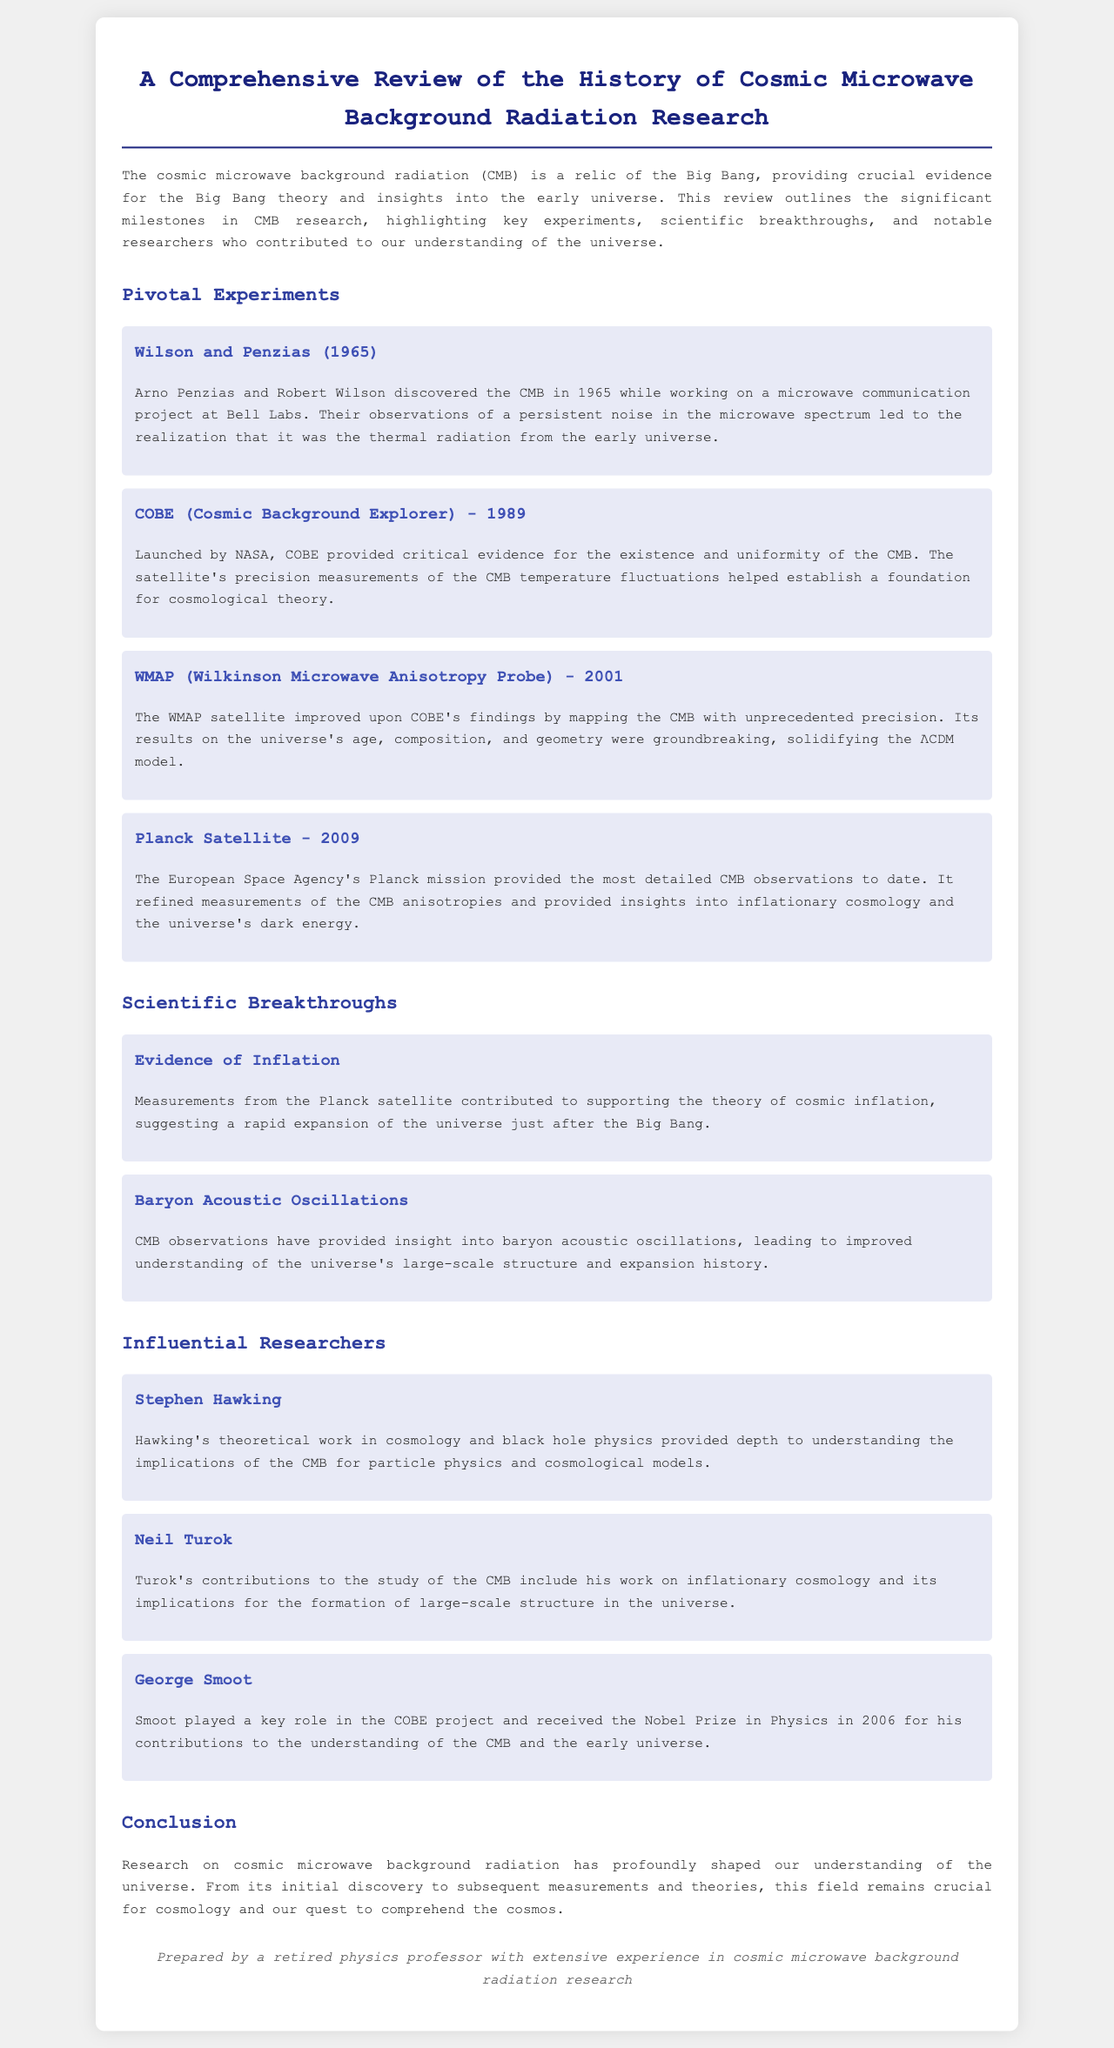What year was the discovery of the CMB? The discovery of the CMB by Arno Penzias and Robert Wilson occurred in 1965.
Answer: 1965 What satellite was launched in 1989 to study the CMB? The COBE satellite was launched by NASA in 1989 to provide critical evidence for the existence of the CMB.
Answer: COBE Who received a Nobel Prize in Physics in 2006 for contributions to the understanding of the CMB? George Smoot played a key role in the COBE project and received the Nobel Prize in Physics in 2006.
Answer: George Smoot What phenomenon do CMB observations provide insights into regarding the universe's large-scale structure? CMB observations have provided insight into baryon acoustic oscillations.
Answer: Baryon Acoustic Oscillations Which experiment refined measurements of the CMB anisotropies in 2009? The Planck mission provided the most detailed CMB observations to date in 2009.
Answer: Planck Satellite What does CMB stand for? The acronym CMB refers to Cosmic Microwave Background radiation.
Answer: Cosmic Microwave Background What major cosmological theory is supported by measurements from the Planck satellite? The theory of cosmic inflation is supported by measurements from the Planck satellite.
Answer: Cosmic Inflation Which researcher contributed to inflationary cosmology and its implications for large-scale structure? Neil Turok’s contributions include work on inflationary cosmology.
Answer: Neil Turok What was a pivotal experiment that mapped the CMB with unprecedented precision in 2001? The WMAP satellite improved upon COBE's findings in 2001.
Answer: WMAP 